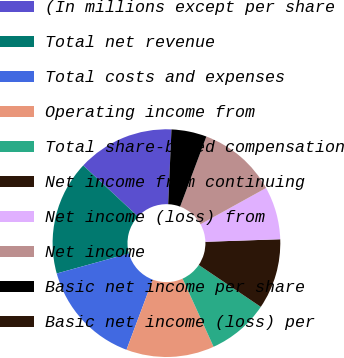Convert chart to OTSL. <chart><loc_0><loc_0><loc_500><loc_500><pie_chart><fcel>(In millions except per share<fcel>Total net revenue<fcel>Total costs and expenses<fcel>Operating income from<fcel>Total share-based compensation<fcel>Net income from continuing<fcel>Net income (loss) from<fcel>Net income<fcel>Basic net income per share<fcel>Basic net income (loss) per<nl><fcel>13.75%<fcel>16.25%<fcel>15.0%<fcel>12.5%<fcel>8.75%<fcel>10.0%<fcel>7.5%<fcel>11.25%<fcel>5.0%<fcel>0.0%<nl></chart> 